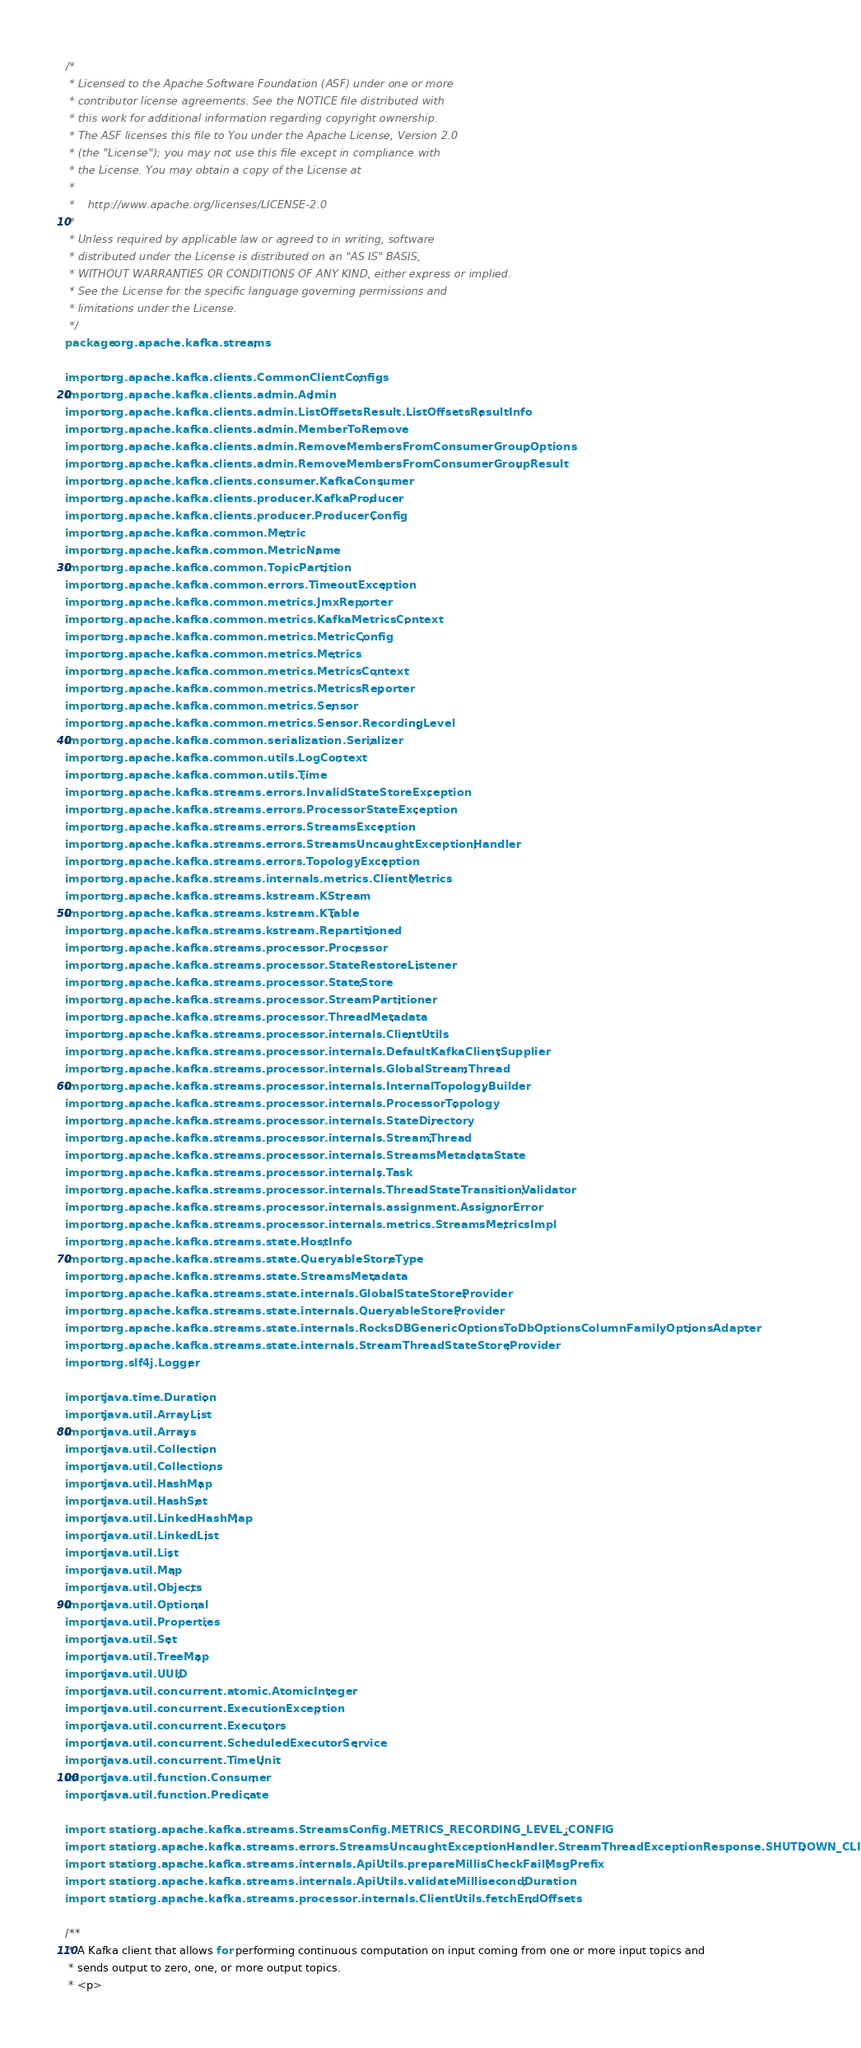Convert code to text. <code><loc_0><loc_0><loc_500><loc_500><_Java_>/*
 * Licensed to the Apache Software Foundation (ASF) under one or more
 * contributor license agreements. See the NOTICE file distributed with
 * this work for additional information regarding copyright ownership.
 * The ASF licenses this file to You under the Apache License, Version 2.0
 * (the "License"); you may not use this file except in compliance with
 * the License. You may obtain a copy of the License at
 *
 *    http://www.apache.org/licenses/LICENSE-2.0
 *
 * Unless required by applicable law or agreed to in writing, software
 * distributed under the License is distributed on an "AS IS" BASIS,
 * WITHOUT WARRANTIES OR CONDITIONS OF ANY KIND, either express or implied.
 * See the License for the specific language governing permissions and
 * limitations under the License.
 */
package org.apache.kafka.streams;

import org.apache.kafka.clients.CommonClientConfigs;
import org.apache.kafka.clients.admin.Admin;
import org.apache.kafka.clients.admin.ListOffsetsResult.ListOffsetsResultInfo;
import org.apache.kafka.clients.admin.MemberToRemove;
import org.apache.kafka.clients.admin.RemoveMembersFromConsumerGroupOptions;
import org.apache.kafka.clients.admin.RemoveMembersFromConsumerGroupResult;
import org.apache.kafka.clients.consumer.KafkaConsumer;
import org.apache.kafka.clients.producer.KafkaProducer;
import org.apache.kafka.clients.producer.ProducerConfig;
import org.apache.kafka.common.Metric;
import org.apache.kafka.common.MetricName;
import org.apache.kafka.common.TopicPartition;
import org.apache.kafka.common.errors.TimeoutException;
import org.apache.kafka.common.metrics.JmxReporter;
import org.apache.kafka.common.metrics.KafkaMetricsContext;
import org.apache.kafka.common.metrics.MetricConfig;
import org.apache.kafka.common.metrics.Metrics;
import org.apache.kafka.common.metrics.MetricsContext;
import org.apache.kafka.common.metrics.MetricsReporter;
import org.apache.kafka.common.metrics.Sensor;
import org.apache.kafka.common.metrics.Sensor.RecordingLevel;
import org.apache.kafka.common.serialization.Serializer;
import org.apache.kafka.common.utils.LogContext;
import org.apache.kafka.common.utils.Time;
import org.apache.kafka.streams.errors.InvalidStateStoreException;
import org.apache.kafka.streams.errors.ProcessorStateException;
import org.apache.kafka.streams.errors.StreamsException;
import org.apache.kafka.streams.errors.StreamsUncaughtExceptionHandler;
import org.apache.kafka.streams.errors.TopologyException;
import org.apache.kafka.streams.internals.metrics.ClientMetrics;
import org.apache.kafka.streams.kstream.KStream;
import org.apache.kafka.streams.kstream.KTable;
import org.apache.kafka.streams.kstream.Repartitioned;
import org.apache.kafka.streams.processor.Processor;
import org.apache.kafka.streams.processor.StateRestoreListener;
import org.apache.kafka.streams.processor.StateStore;
import org.apache.kafka.streams.processor.StreamPartitioner;
import org.apache.kafka.streams.processor.ThreadMetadata;
import org.apache.kafka.streams.processor.internals.ClientUtils;
import org.apache.kafka.streams.processor.internals.DefaultKafkaClientSupplier;
import org.apache.kafka.streams.processor.internals.GlobalStreamThread;
import org.apache.kafka.streams.processor.internals.InternalTopologyBuilder;
import org.apache.kafka.streams.processor.internals.ProcessorTopology;
import org.apache.kafka.streams.processor.internals.StateDirectory;
import org.apache.kafka.streams.processor.internals.StreamThread;
import org.apache.kafka.streams.processor.internals.StreamsMetadataState;
import org.apache.kafka.streams.processor.internals.Task;
import org.apache.kafka.streams.processor.internals.ThreadStateTransitionValidator;
import org.apache.kafka.streams.processor.internals.assignment.AssignorError;
import org.apache.kafka.streams.processor.internals.metrics.StreamsMetricsImpl;
import org.apache.kafka.streams.state.HostInfo;
import org.apache.kafka.streams.state.QueryableStoreType;
import org.apache.kafka.streams.state.StreamsMetadata;
import org.apache.kafka.streams.state.internals.GlobalStateStoreProvider;
import org.apache.kafka.streams.state.internals.QueryableStoreProvider;
import org.apache.kafka.streams.state.internals.RocksDBGenericOptionsToDbOptionsColumnFamilyOptionsAdapter;
import org.apache.kafka.streams.state.internals.StreamThreadStateStoreProvider;
import org.slf4j.Logger;

import java.time.Duration;
import java.util.ArrayList;
import java.util.Arrays;
import java.util.Collection;
import java.util.Collections;
import java.util.HashMap;
import java.util.HashSet;
import java.util.LinkedHashMap;
import java.util.LinkedList;
import java.util.List;
import java.util.Map;
import java.util.Objects;
import java.util.Optional;
import java.util.Properties;
import java.util.Set;
import java.util.TreeMap;
import java.util.UUID;
import java.util.concurrent.atomic.AtomicInteger;
import java.util.concurrent.ExecutionException;
import java.util.concurrent.Executors;
import java.util.concurrent.ScheduledExecutorService;
import java.util.concurrent.TimeUnit;
import java.util.function.Consumer;
import java.util.function.Predicate;

import static org.apache.kafka.streams.StreamsConfig.METRICS_RECORDING_LEVEL_CONFIG;
import static org.apache.kafka.streams.errors.StreamsUncaughtExceptionHandler.StreamThreadExceptionResponse.SHUTDOWN_CLIENT;
import static org.apache.kafka.streams.internals.ApiUtils.prepareMillisCheckFailMsgPrefix;
import static org.apache.kafka.streams.internals.ApiUtils.validateMillisecondDuration;
import static org.apache.kafka.streams.processor.internals.ClientUtils.fetchEndOffsets;

/**
 * A Kafka client that allows for performing continuous computation on input coming from one or more input topics and
 * sends output to zero, one, or more output topics.
 * <p></code> 